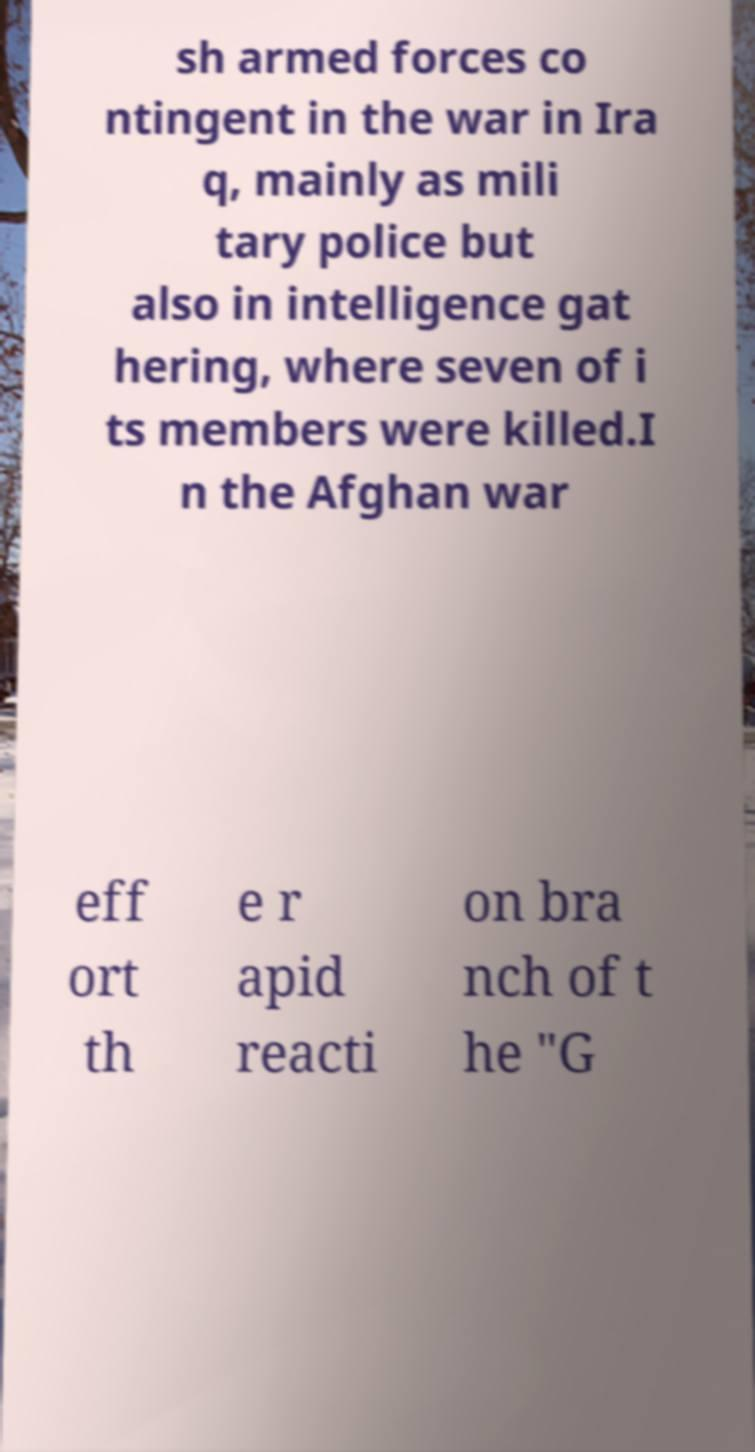Please identify and transcribe the text found in this image. sh armed forces co ntingent in the war in Ira q, mainly as mili tary police but also in intelligence gat hering, where seven of i ts members were killed.I n the Afghan war eff ort th e r apid reacti on bra nch of t he "G 